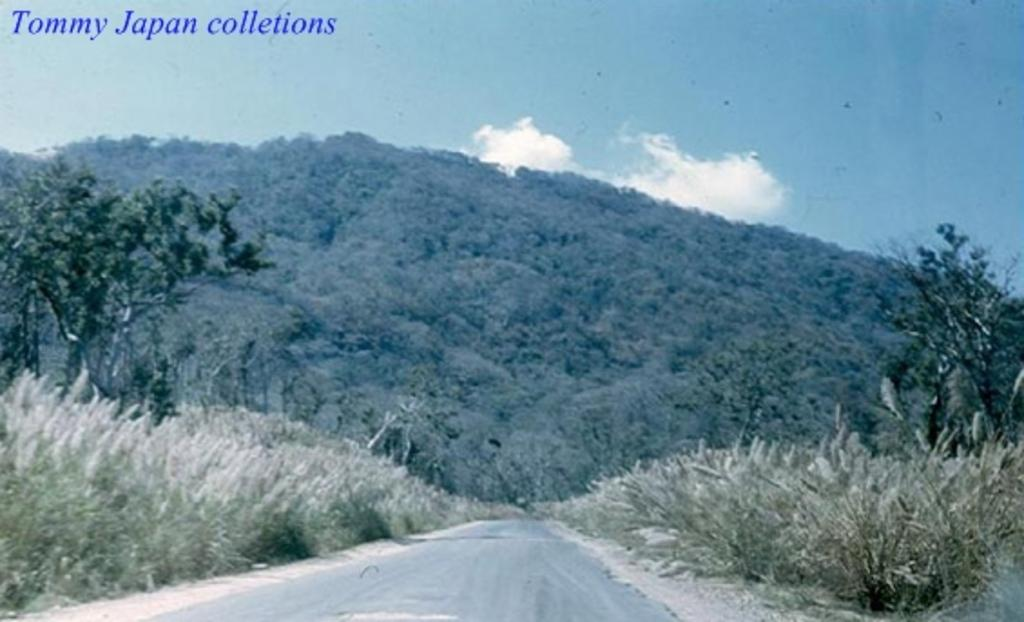What type of vegetation can be seen in the image? There are trees in the image. What is the condition of the ground in the image? There is dry grass in the image. What is visible in the sky in the image? The sky is cloudy in the image. What type of linen can be seen draped over the trees in the image? There is no linen present in the image; it only features trees, dry grass, and a cloudy sky. 